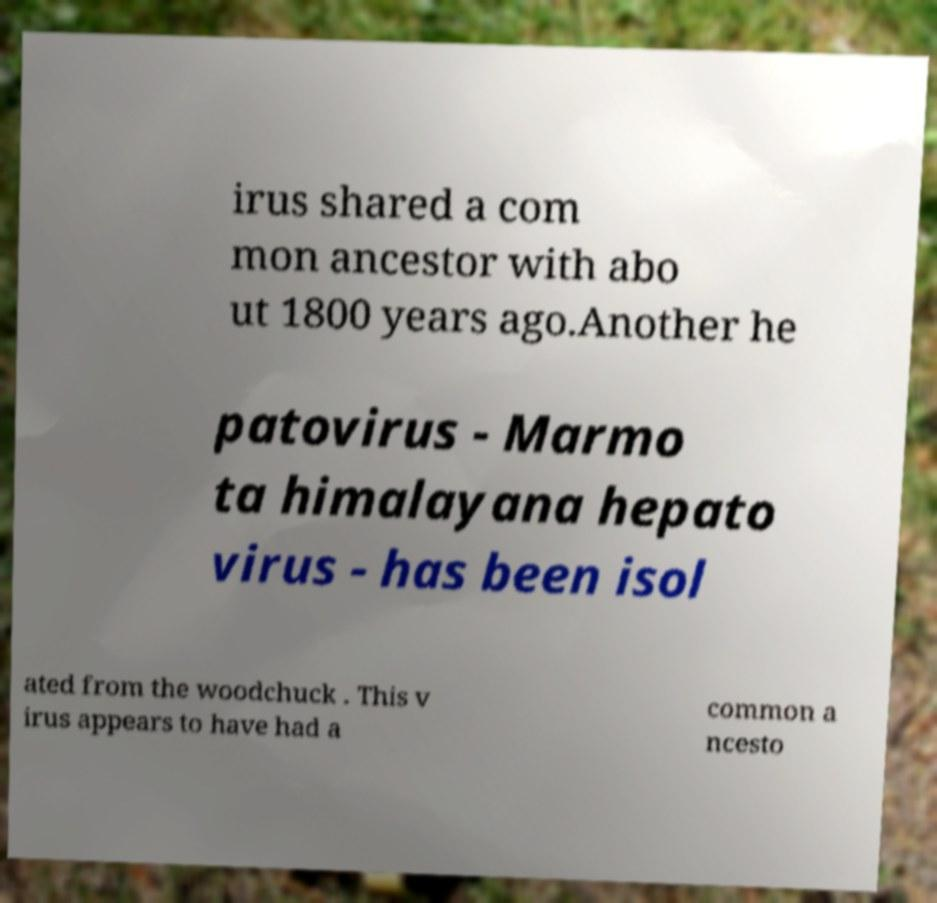Can you accurately transcribe the text from the provided image for me? irus shared a com mon ancestor with abo ut 1800 years ago.Another he patovirus - Marmo ta himalayana hepato virus - has been isol ated from the woodchuck . This v irus appears to have had a common a ncesto 